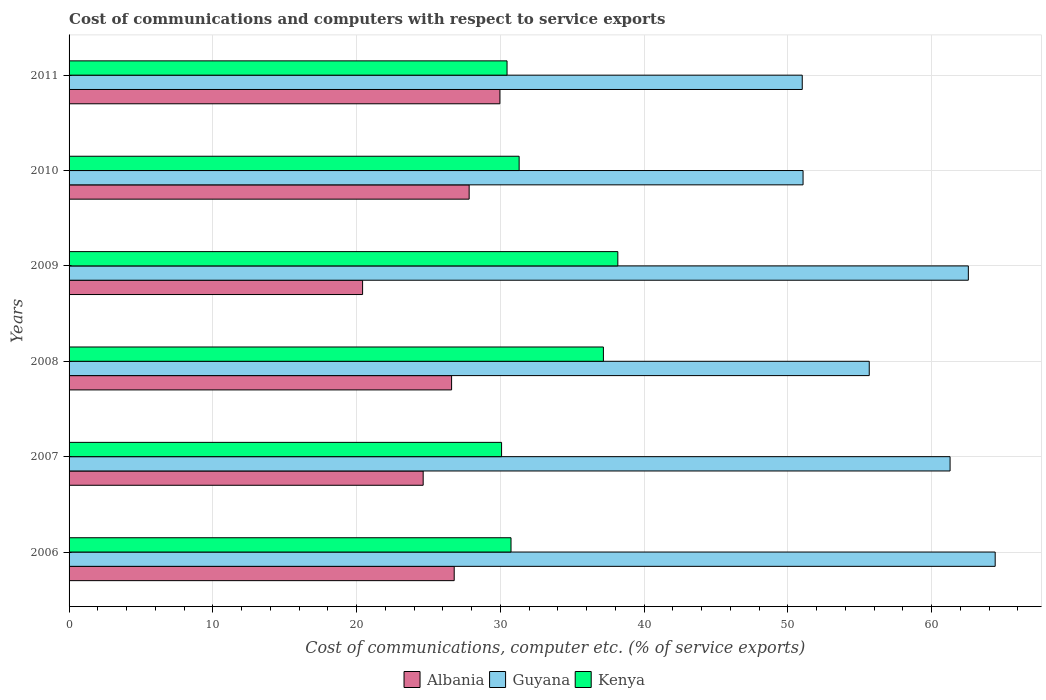How many different coloured bars are there?
Keep it short and to the point. 3. Are the number of bars per tick equal to the number of legend labels?
Your answer should be very brief. Yes. How many bars are there on the 6th tick from the bottom?
Ensure brevity in your answer.  3. What is the label of the 1st group of bars from the top?
Ensure brevity in your answer.  2011. In how many cases, is the number of bars for a given year not equal to the number of legend labels?
Your response must be concise. 0. What is the cost of communications and computers in Albania in 2008?
Ensure brevity in your answer.  26.61. Across all years, what is the maximum cost of communications and computers in Albania?
Offer a very short reply. 29.97. Across all years, what is the minimum cost of communications and computers in Guyana?
Ensure brevity in your answer.  51. In which year was the cost of communications and computers in Guyana minimum?
Offer a terse response. 2011. What is the total cost of communications and computers in Kenya in the graph?
Keep it short and to the point. 197.94. What is the difference between the cost of communications and computers in Albania in 2009 and that in 2010?
Ensure brevity in your answer.  -7.41. What is the difference between the cost of communications and computers in Albania in 2010 and the cost of communications and computers in Guyana in 2008?
Ensure brevity in your answer.  -27.83. What is the average cost of communications and computers in Guyana per year?
Your answer should be compact. 57.66. In the year 2010, what is the difference between the cost of communications and computers in Albania and cost of communications and computers in Kenya?
Offer a terse response. -3.48. What is the ratio of the cost of communications and computers in Guyana in 2008 to that in 2011?
Your response must be concise. 1.09. Is the difference between the cost of communications and computers in Albania in 2007 and 2010 greater than the difference between the cost of communications and computers in Kenya in 2007 and 2010?
Your response must be concise. No. What is the difference between the highest and the second highest cost of communications and computers in Albania?
Provide a short and direct response. 2.14. What is the difference between the highest and the lowest cost of communications and computers in Albania?
Make the answer very short. 9.55. In how many years, is the cost of communications and computers in Albania greater than the average cost of communications and computers in Albania taken over all years?
Your response must be concise. 4. Is the sum of the cost of communications and computers in Guyana in 2007 and 2009 greater than the maximum cost of communications and computers in Albania across all years?
Offer a terse response. Yes. What does the 2nd bar from the top in 2011 represents?
Ensure brevity in your answer.  Guyana. What does the 1st bar from the bottom in 2006 represents?
Offer a terse response. Albania. How many bars are there?
Provide a succinct answer. 18. Are all the bars in the graph horizontal?
Offer a terse response. Yes. How many years are there in the graph?
Ensure brevity in your answer.  6. What is the difference between two consecutive major ticks on the X-axis?
Your response must be concise. 10. Does the graph contain grids?
Provide a succinct answer. Yes. How many legend labels are there?
Ensure brevity in your answer.  3. What is the title of the graph?
Offer a terse response. Cost of communications and computers with respect to service exports. Does "Malawi" appear as one of the legend labels in the graph?
Make the answer very short. No. What is the label or title of the X-axis?
Ensure brevity in your answer.  Cost of communications, computer etc. (% of service exports). What is the Cost of communications, computer etc. (% of service exports) in Albania in 2006?
Your response must be concise. 26.79. What is the Cost of communications, computer etc. (% of service exports) of Guyana in 2006?
Provide a succinct answer. 64.42. What is the Cost of communications, computer etc. (% of service exports) in Kenya in 2006?
Give a very brief answer. 30.74. What is the Cost of communications, computer etc. (% of service exports) in Albania in 2007?
Make the answer very short. 24.63. What is the Cost of communications, computer etc. (% of service exports) in Guyana in 2007?
Your response must be concise. 61.28. What is the Cost of communications, computer etc. (% of service exports) of Kenya in 2007?
Provide a short and direct response. 30.09. What is the Cost of communications, computer etc. (% of service exports) in Albania in 2008?
Provide a short and direct response. 26.61. What is the Cost of communications, computer etc. (% of service exports) in Guyana in 2008?
Ensure brevity in your answer.  55.66. What is the Cost of communications, computer etc. (% of service exports) of Kenya in 2008?
Your answer should be very brief. 37.17. What is the Cost of communications, computer etc. (% of service exports) of Albania in 2009?
Your response must be concise. 20.42. What is the Cost of communications, computer etc. (% of service exports) of Guyana in 2009?
Offer a very short reply. 62.55. What is the Cost of communications, computer etc. (% of service exports) in Kenya in 2009?
Make the answer very short. 38.17. What is the Cost of communications, computer etc. (% of service exports) in Albania in 2010?
Your response must be concise. 27.83. What is the Cost of communications, computer etc. (% of service exports) of Guyana in 2010?
Give a very brief answer. 51.06. What is the Cost of communications, computer etc. (% of service exports) of Kenya in 2010?
Give a very brief answer. 31.31. What is the Cost of communications, computer etc. (% of service exports) in Albania in 2011?
Give a very brief answer. 29.97. What is the Cost of communications, computer etc. (% of service exports) in Guyana in 2011?
Your answer should be compact. 51. What is the Cost of communications, computer etc. (% of service exports) of Kenya in 2011?
Ensure brevity in your answer.  30.47. Across all years, what is the maximum Cost of communications, computer etc. (% of service exports) in Albania?
Ensure brevity in your answer.  29.97. Across all years, what is the maximum Cost of communications, computer etc. (% of service exports) of Guyana?
Make the answer very short. 64.42. Across all years, what is the maximum Cost of communications, computer etc. (% of service exports) in Kenya?
Your answer should be very brief. 38.17. Across all years, what is the minimum Cost of communications, computer etc. (% of service exports) in Albania?
Your answer should be very brief. 20.42. Across all years, what is the minimum Cost of communications, computer etc. (% of service exports) of Guyana?
Keep it short and to the point. 51. Across all years, what is the minimum Cost of communications, computer etc. (% of service exports) of Kenya?
Your answer should be compact. 30.09. What is the total Cost of communications, computer etc. (% of service exports) of Albania in the graph?
Your answer should be compact. 156.25. What is the total Cost of communications, computer etc. (% of service exports) in Guyana in the graph?
Provide a succinct answer. 345.98. What is the total Cost of communications, computer etc. (% of service exports) of Kenya in the graph?
Give a very brief answer. 197.94. What is the difference between the Cost of communications, computer etc. (% of service exports) of Albania in 2006 and that in 2007?
Keep it short and to the point. 2.16. What is the difference between the Cost of communications, computer etc. (% of service exports) in Guyana in 2006 and that in 2007?
Offer a terse response. 3.14. What is the difference between the Cost of communications, computer etc. (% of service exports) of Kenya in 2006 and that in 2007?
Provide a succinct answer. 0.66. What is the difference between the Cost of communications, computer etc. (% of service exports) in Albania in 2006 and that in 2008?
Give a very brief answer. 0.18. What is the difference between the Cost of communications, computer etc. (% of service exports) of Guyana in 2006 and that in 2008?
Give a very brief answer. 8.76. What is the difference between the Cost of communications, computer etc. (% of service exports) of Kenya in 2006 and that in 2008?
Offer a very short reply. -6.43. What is the difference between the Cost of communications, computer etc. (% of service exports) of Albania in 2006 and that in 2009?
Keep it short and to the point. 6.37. What is the difference between the Cost of communications, computer etc. (% of service exports) of Guyana in 2006 and that in 2009?
Your response must be concise. 1.87. What is the difference between the Cost of communications, computer etc. (% of service exports) in Kenya in 2006 and that in 2009?
Offer a terse response. -7.43. What is the difference between the Cost of communications, computer etc. (% of service exports) of Albania in 2006 and that in 2010?
Make the answer very short. -1.04. What is the difference between the Cost of communications, computer etc. (% of service exports) in Guyana in 2006 and that in 2010?
Your answer should be compact. 13.36. What is the difference between the Cost of communications, computer etc. (% of service exports) of Kenya in 2006 and that in 2010?
Offer a very short reply. -0.56. What is the difference between the Cost of communications, computer etc. (% of service exports) in Albania in 2006 and that in 2011?
Keep it short and to the point. -3.18. What is the difference between the Cost of communications, computer etc. (% of service exports) in Guyana in 2006 and that in 2011?
Your answer should be very brief. 13.42. What is the difference between the Cost of communications, computer etc. (% of service exports) in Kenya in 2006 and that in 2011?
Your answer should be very brief. 0.28. What is the difference between the Cost of communications, computer etc. (% of service exports) in Albania in 2007 and that in 2008?
Your response must be concise. -1.98. What is the difference between the Cost of communications, computer etc. (% of service exports) of Guyana in 2007 and that in 2008?
Your answer should be compact. 5.62. What is the difference between the Cost of communications, computer etc. (% of service exports) of Kenya in 2007 and that in 2008?
Your answer should be compact. -7.08. What is the difference between the Cost of communications, computer etc. (% of service exports) in Albania in 2007 and that in 2009?
Ensure brevity in your answer.  4.21. What is the difference between the Cost of communications, computer etc. (% of service exports) of Guyana in 2007 and that in 2009?
Your response must be concise. -1.27. What is the difference between the Cost of communications, computer etc. (% of service exports) in Kenya in 2007 and that in 2009?
Ensure brevity in your answer.  -8.09. What is the difference between the Cost of communications, computer etc. (% of service exports) in Albania in 2007 and that in 2010?
Your answer should be compact. -3.2. What is the difference between the Cost of communications, computer etc. (% of service exports) in Guyana in 2007 and that in 2010?
Make the answer very short. 10.23. What is the difference between the Cost of communications, computer etc. (% of service exports) in Kenya in 2007 and that in 2010?
Keep it short and to the point. -1.22. What is the difference between the Cost of communications, computer etc. (% of service exports) of Albania in 2007 and that in 2011?
Offer a terse response. -5.34. What is the difference between the Cost of communications, computer etc. (% of service exports) of Guyana in 2007 and that in 2011?
Provide a short and direct response. 10.28. What is the difference between the Cost of communications, computer etc. (% of service exports) of Kenya in 2007 and that in 2011?
Keep it short and to the point. -0.38. What is the difference between the Cost of communications, computer etc. (% of service exports) in Albania in 2008 and that in 2009?
Keep it short and to the point. 6.19. What is the difference between the Cost of communications, computer etc. (% of service exports) of Guyana in 2008 and that in 2009?
Provide a short and direct response. -6.89. What is the difference between the Cost of communications, computer etc. (% of service exports) in Kenya in 2008 and that in 2009?
Ensure brevity in your answer.  -1. What is the difference between the Cost of communications, computer etc. (% of service exports) of Albania in 2008 and that in 2010?
Offer a very short reply. -1.22. What is the difference between the Cost of communications, computer etc. (% of service exports) in Guyana in 2008 and that in 2010?
Offer a very short reply. 4.6. What is the difference between the Cost of communications, computer etc. (% of service exports) of Kenya in 2008 and that in 2010?
Provide a succinct answer. 5.86. What is the difference between the Cost of communications, computer etc. (% of service exports) in Albania in 2008 and that in 2011?
Make the answer very short. -3.36. What is the difference between the Cost of communications, computer etc. (% of service exports) of Guyana in 2008 and that in 2011?
Make the answer very short. 4.66. What is the difference between the Cost of communications, computer etc. (% of service exports) of Kenya in 2008 and that in 2011?
Make the answer very short. 6.7. What is the difference between the Cost of communications, computer etc. (% of service exports) in Albania in 2009 and that in 2010?
Offer a very short reply. -7.41. What is the difference between the Cost of communications, computer etc. (% of service exports) in Guyana in 2009 and that in 2010?
Keep it short and to the point. 11.5. What is the difference between the Cost of communications, computer etc. (% of service exports) in Kenya in 2009 and that in 2010?
Your response must be concise. 6.87. What is the difference between the Cost of communications, computer etc. (% of service exports) in Albania in 2009 and that in 2011?
Provide a short and direct response. -9.55. What is the difference between the Cost of communications, computer etc. (% of service exports) of Guyana in 2009 and that in 2011?
Provide a succinct answer. 11.55. What is the difference between the Cost of communications, computer etc. (% of service exports) of Kenya in 2009 and that in 2011?
Provide a short and direct response. 7.71. What is the difference between the Cost of communications, computer etc. (% of service exports) in Albania in 2010 and that in 2011?
Your response must be concise. -2.14. What is the difference between the Cost of communications, computer etc. (% of service exports) of Guyana in 2010 and that in 2011?
Your answer should be compact. 0.06. What is the difference between the Cost of communications, computer etc. (% of service exports) of Kenya in 2010 and that in 2011?
Provide a short and direct response. 0.84. What is the difference between the Cost of communications, computer etc. (% of service exports) in Albania in 2006 and the Cost of communications, computer etc. (% of service exports) in Guyana in 2007?
Your response must be concise. -34.49. What is the difference between the Cost of communications, computer etc. (% of service exports) in Albania in 2006 and the Cost of communications, computer etc. (% of service exports) in Kenya in 2007?
Your response must be concise. -3.3. What is the difference between the Cost of communications, computer etc. (% of service exports) of Guyana in 2006 and the Cost of communications, computer etc. (% of service exports) of Kenya in 2007?
Your answer should be very brief. 34.34. What is the difference between the Cost of communications, computer etc. (% of service exports) of Albania in 2006 and the Cost of communications, computer etc. (% of service exports) of Guyana in 2008?
Your response must be concise. -28.87. What is the difference between the Cost of communications, computer etc. (% of service exports) of Albania in 2006 and the Cost of communications, computer etc. (% of service exports) of Kenya in 2008?
Your response must be concise. -10.38. What is the difference between the Cost of communications, computer etc. (% of service exports) in Guyana in 2006 and the Cost of communications, computer etc. (% of service exports) in Kenya in 2008?
Give a very brief answer. 27.25. What is the difference between the Cost of communications, computer etc. (% of service exports) of Albania in 2006 and the Cost of communications, computer etc. (% of service exports) of Guyana in 2009?
Provide a short and direct response. -35.76. What is the difference between the Cost of communications, computer etc. (% of service exports) in Albania in 2006 and the Cost of communications, computer etc. (% of service exports) in Kenya in 2009?
Offer a very short reply. -11.38. What is the difference between the Cost of communications, computer etc. (% of service exports) of Guyana in 2006 and the Cost of communications, computer etc. (% of service exports) of Kenya in 2009?
Offer a very short reply. 26.25. What is the difference between the Cost of communications, computer etc. (% of service exports) of Albania in 2006 and the Cost of communications, computer etc. (% of service exports) of Guyana in 2010?
Ensure brevity in your answer.  -24.27. What is the difference between the Cost of communications, computer etc. (% of service exports) of Albania in 2006 and the Cost of communications, computer etc. (% of service exports) of Kenya in 2010?
Give a very brief answer. -4.52. What is the difference between the Cost of communications, computer etc. (% of service exports) in Guyana in 2006 and the Cost of communications, computer etc. (% of service exports) in Kenya in 2010?
Make the answer very short. 33.11. What is the difference between the Cost of communications, computer etc. (% of service exports) in Albania in 2006 and the Cost of communications, computer etc. (% of service exports) in Guyana in 2011?
Offer a terse response. -24.21. What is the difference between the Cost of communications, computer etc. (% of service exports) in Albania in 2006 and the Cost of communications, computer etc. (% of service exports) in Kenya in 2011?
Provide a succinct answer. -3.68. What is the difference between the Cost of communications, computer etc. (% of service exports) of Guyana in 2006 and the Cost of communications, computer etc. (% of service exports) of Kenya in 2011?
Offer a very short reply. 33.96. What is the difference between the Cost of communications, computer etc. (% of service exports) of Albania in 2007 and the Cost of communications, computer etc. (% of service exports) of Guyana in 2008?
Provide a short and direct response. -31.03. What is the difference between the Cost of communications, computer etc. (% of service exports) of Albania in 2007 and the Cost of communications, computer etc. (% of service exports) of Kenya in 2008?
Provide a short and direct response. -12.54. What is the difference between the Cost of communications, computer etc. (% of service exports) of Guyana in 2007 and the Cost of communications, computer etc. (% of service exports) of Kenya in 2008?
Your answer should be compact. 24.12. What is the difference between the Cost of communications, computer etc. (% of service exports) in Albania in 2007 and the Cost of communications, computer etc. (% of service exports) in Guyana in 2009?
Your answer should be compact. -37.92. What is the difference between the Cost of communications, computer etc. (% of service exports) of Albania in 2007 and the Cost of communications, computer etc. (% of service exports) of Kenya in 2009?
Your answer should be compact. -13.54. What is the difference between the Cost of communications, computer etc. (% of service exports) in Guyana in 2007 and the Cost of communications, computer etc. (% of service exports) in Kenya in 2009?
Your response must be concise. 23.11. What is the difference between the Cost of communications, computer etc. (% of service exports) in Albania in 2007 and the Cost of communications, computer etc. (% of service exports) in Guyana in 2010?
Provide a succinct answer. -26.43. What is the difference between the Cost of communications, computer etc. (% of service exports) in Albania in 2007 and the Cost of communications, computer etc. (% of service exports) in Kenya in 2010?
Offer a terse response. -6.68. What is the difference between the Cost of communications, computer etc. (% of service exports) in Guyana in 2007 and the Cost of communications, computer etc. (% of service exports) in Kenya in 2010?
Provide a succinct answer. 29.98. What is the difference between the Cost of communications, computer etc. (% of service exports) in Albania in 2007 and the Cost of communications, computer etc. (% of service exports) in Guyana in 2011?
Offer a terse response. -26.37. What is the difference between the Cost of communications, computer etc. (% of service exports) of Albania in 2007 and the Cost of communications, computer etc. (% of service exports) of Kenya in 2011?
Give a very brief answer. -5.83. What is the difference between the Cost of communications, computer etc. (% of service exports) in Guyana in 2007 and the Cost of communications, computer etc. (% of service exports) in Kenya in 2011?
Offer a very short reply. 30.82. What is the difference between the Cost of communications, computer etc. (% of service exports) of Albania in 2008 and the Cost of communications, computer etc. (% of service exports) of Guyana in 2009?
Your answer should be very brief. -35.95. What is the difference between the Cost of communications, computer etc. (% of service exports) in Albania in 2008 and the Cost of communications, computer etc. (% of service exports) in Kenya in 2009?
Your answer should be very brief. -11.56. What is the difference between the Cost of communications, computer etc. (% of service exports) of Guyana in 2008 and the Cost of communications, computer etc. (% of service exports) of Kenya in 2009?
Keep it short and to the point. 17.49. What is the difference between the Cost of communications, computer etc. (% of service exports) of Albania in 2008 and the Cost of communications, computer etc. (% of service exports) of Guyana in 2010?
Provide a succinct answer. -24.45. What is the difference between the Cost of communications, computer etc. (% of service exports) of Albania in 2008 and the Cost of communications, computer etc. (% of service exports) of Kenya in 2010?
Provide a succinct answer. -4.7. What is the difference between the Cost of communications, computer etc. (% of service exports) in Guyana in 2008 and the Cost of communications, computer etc. (% of service exports) in Kenya in 2010?
Ensure brevity in your answer.  24.35. What is the difference between the Cost of communications, computer etc. (% of service exports) of Albania in 2008 and the Cost of communications, computer etc. (% of service exports) of Guyana in 2011?
Offer a very short reply. -24.39. What is the difference between the Cost of communications, computer etc. (% of service exports) of Albania in 2008 and the Cost of communications, computer etc. (% of service exports) of Kenya in 2011?
Offer a terse response. -3.86. What is the difference between the Cost of communications, computer etc. (% of service exports) of Guyana in 2008 and the Cost of communications, computer etc. (% of service exports) of Kenya in 2011?
Your answer should be compact. 25.2. What is the difference between the Cost of communications, computer etc. (% of service exports) in Albania in 2009 and the Cost of communications, computer etc. (% of service exports) in Guyana in 2010?
Your answer should be very brief. -30.64. What is the difference between the Cost of communications, computer etc. (% of service exports) of Albania in 2009 and the Cost of communications, computer etc. (% of service exports) of Kenya in 2010?
Ensure brevity in your answer.  -10.89. What is the difference between the Cost of communications, computer etc. (% of service exports) in Guyana in 2009 and the Cost of communications, computer etc. (% of service exports) in Kenya in 2010?
Ensure brevity in your answer.  31.25. What is the difference between the Cost of communications, computer etc. (% of service exports) in Albania in 2009 and the Cost of communications, computer etc. (% of service exports) in Guyana in 2011?
Your answer should be compact. -30.58. What is the difference between the Cost of communications, computer etc. (% of service exports) of Albania in 2009 and the Cost of communications, computer etc. (% of service exports) of Kenya in 2011?
Provide a short and direct response. -10.05. What is the difference between the Cost of communications, computer etc. (% of service exports) of Guyana in 2009 and the Cost of communications, computer etc. (% of service exports) of Kenya in 2011?
Provide a succinct answer. 32.09. What is the difference between the Cost of communications, computer etc. (% of service exports) in Albania in 2010 and the Cost of communications, computer etc. (% of service exports) in Guyana in 2011?
Make the answer very short. -23.17. What is the difference between the Cost of communications, computer etc. (% of service exports) in Albania in 2010 and the Cost of communications, computer etc. (% of service exports) in Kenya in 2011?
Make the answer very short. -2.63. What is the difference between the Cost of communications, computer etc. (% of service exports) in Guyana in 2010 and the Cost of communications, computer etc. (% of service exports) in Kenya in 2011?
Provide a succinct answer. 20.59. What is the average Cost of communications, computer etc. (% of service exports) in Albania per year?
Offer a very short reply. 26.04. What is the average Cost of communications, computer etc. (% of service exports) in Guyana per year?
Your answer should be very brief. 57.66. What is the average Cost of communications, computer etc. (% of service exports) of Kenya per year?
Offer a terse response. 32.99. In the year 2006, what is the difference between the Cost of communications, computer etc. (% of service exports) in Albania and Cost of communications, computer etc. (% of service exports) in Guyana?
Your answer should be compact. -37.63. In the year 2006, what is the difference between the Cost of communications, computer etc. (% of service exports) in Albania and Cost of communications, computer etc. (% of service exports) in Kenya?
Give a very brief answer. -3.95. In the year 2006, what is the difference between the Cost of communications, computer etc. (% of service exports) of Guyana and Cost of communications, computer etc. (% of service exports) of Kenya?
Ensure brevity in your answer.  33.68. In the year 2007, what is the difference between the Cost of communications, computer etc. (% of service exports) of Albania and Cost of communications, computer etc. (% of service exports) of Guyana?
Give a very brief answer. -36.65. In the year 2007, what is the difference between the Cost of communications, computer etc. (% of service exports) in Albania and Cost of communications, computer etc. (% of service exports) in Kenya?
Keep it short and to the point. -5.45. In the year 2007, what is the difference between the Cost of communications, computer etc. (% of service exports) of Guyana and Cost of communications, computer etc. (% of service exports) of Kenya?
Give a very brief answer. 31.2. In the year 2008, what is the difference between the Cost of communications, computer etc. (% of service exports) of Albania and Cost of communications, computer etc. (% of service exports) of Guyana?
Your answer should be very brief. -29.05. In the year 2008, what is the difference between the Cost of communications, computer etc. (% of service exports) of Albania and Cost of communications, computer etc. (% of service exports) of Kenya?
Your answer should be very brief. -10.56. In the year 2008, what is the difference between the Cost of communications, computer etc. (% of service exports) in Guyana and Cost of communications, computer etc. (% of service exports) in Kenya?
Keep it short and to the point. 18.49. In the year 2009, what is the difference between the Cost of communications, computer etc. (% of service exports) in Albania and Cost of communications, computer etc. (% of service exports) in Guyana?
Give a very brief answer. -42.14. In the year 2009, what is the difference between the Cost of communications, computer etc. (% of service exports) of Albania and Cost of communications, computer etc. (% of service exports) of Kenya?
Offer a very short reply. -17.76. In the year 2009, what is the difference between the Cost of communications, computer etc. (% of service exports) in Guyana and Cost of communications, computer etc. (% of service exports) in Kenya?
Ensure brevity in your answer.  24.38. In the year 2010, what is the difference between the Cost of communications, computer etc. (% of service exports) of Albania and Cost of communications, computer etc. (% of service exports) of Guyana?
Ensure brevity in your answer.  -23.23. In the year 2010, what is the difference between the Cost of communications, computer etc. (% of service exports) in Albania and Cost of communications, computer etc. (% of service exports) in Kenya?
Offer a terse response. -3.48. In the year 2010, what is the difference between the Cost of communications, computer etc. (% of service exports) of Guyana and Cost of communications, computer etc. (% of service exports) of Kenya?
Your answer should be very brief. 19.75. In the year 2011, what is the difference between the Cost of communications, computer etc. (% of service exports) in Albania and Cost of communications, computer etc. (% of service exports) in Guyana?
Ensure brevity in your answer.  -21.03. In the year 2011, what is the difference between the Cost of communications, computer etc. (% of service exports) in Albania and Cost of communications, computer etc. (% of service exports) in Kenya?
Your answer should be compact. -0.5. In the year 2011, what is the difference between the Cost of communications, computer etc. (% of service exports) of Guyana and Cost of communications, computer etc. (% of service exports) of Kenya?
Ensure brevity in your answer.  20.53. What is the ratio of the Cost of communications, computer etc. (% of service exports) in Albania in 2006 to that in 2007?
Ensure brevity in your answer.  1.09. What is the ratio of the Cost of communications, computer etc. (% of service exports) of Guyana in 2006 to that in 2007?
Offer a terse response. 1.05. What is the ratio of the Cost of communications, computer etc. (% of service exports) of Kenya in 2006 to that in 2007?
Ensure brevity in your answer.  1.02. What is the ratio of the Cost of communications, computer etc. (% of service exports) of Albania in 2006 to that in 2008?
Make the answer very short. 1.01. What is the ratio of the Cost of communications, computer etc. (% of service exports) of Guyana in 2006 to that in 2008?
Provide a succinct answer. 1.16. What is the ratio of the Cost of communications, computer etc. (% of service exports) of Kenya in 2006 to that in 2008?
Your response must be concise. 0.83. What is the ratio of the Cost of communications, computer etc. (% of service exports) of Albania in 2006 to that in 2009?
Your response must be concise. 1.31. What is the ratio of the Cost of communications, computer etc. (% of service exports) of Guyana in 2006 to that in 2009?
Ensure brevity in your answer.  1.03. What is the ratio of the Cost of communications, computer etc. (% of service exports) of Kenya in 2006 to that in 2009?
Give a very brief answer. 0.81. What is the ratio of the Cost of communications, computer etc. (% of service exports) in Albania in 2006 to that in 2010?
Keep it short and to the point. 0.96. What is the ratio of the Cost of communications, computer etc. (% of service exports) in Guyana in 2006 to that in 2010?
Keep it short and to the point. 1.26. What is the ratio of the Cost of communications, computer etc. (% of service exports) of Albania in 2006 to that in 2011?
Your answer should be very brief. 0.89. What is the ratio of the Cost of communications, computer etc. (% of service exports) in Guyana in 2006 to that in 2011?
Your answer should be compact. 1.26. What is the ratio of the Cost of communications, computer etc. (% of service exports) in Kenya in 2006 to that in 2011?
Your response must be concise. 1.01. What is the ratio of the Cost of communications, computer etc. (% of service exports) in Albania in 2007 to that in 2008?
Give a very brief answer. 0.93. What is the ratio of the Cost of communications, computer etc. (% of service exports) in Guyana in 2007 to that in 2008?
Provide a succinct answer. 1.1. What is the ratio of the Cost of communications, computer etc. (% of service exports) of Kenya in 2007 to that in 2008?
Offer a very short reply. 0.81. What is the ratio of the Cost of communications, computer etc. (% of service exports) in Albania in 2007 to that in 2009?
Offer a very short reply. 1.21. What is the ratio of the Cost of communications, computer etc. (% of service exports) of Guyana in 2007 to that in 2009?
Offer a very short reply. 0.98. What is the ratio of the Cost of communications, computer etc. (% of service exports) of Kenya in 2007 to that in 2009?
Your answer should be very brief. 0.79. What is the ratio of the Cost of communications, computer etc. (% of service exports) of Albania in 2007 to that in 2010?
Offer a very short reply. 0.89. What is the ratio of the Cost of communications, computer etc. (% of service exports) of Guyana in 2007 to that in 2010?
Ensure brevity in your answer.  1.2. What is the ratio of the Cost of communications, computer etc. (% of service exports) in Kenya in 2007 to that in 2010?
Offer a very short reply. 0.96. What is the ratio of the Cost of communications, computer etc. (% of service exports) in Albania in 2007 to that in 2011?
Keep it short and to the point. 0.82. What is the ratio of the Cost of communications, computer etc. (% of service exports) of Guyana in 2007 to that in 2011?
Keep it short and to the point. 1.2. What is the ratio of the Cost of communications, computer etc. (% of service exports) of Kenya in 2007 to that in 2011?
Offer a very short reply. 0.99. What is the ratio of the Cost of communications, computer etc. (% of service exports) of Albania in 2008 to that in 2009?
Give a very brief answer. 1.3. What is the ratio of the Cost of communications, computer etc. (% of service exports) in Guyana in 2008 to that in 2009?
Offer a terse response. 0.89. What is the ratio of the Cost of communications, computer etc. (% of service exports) in Kenya in 2008 to that in 2009?
Provide a succinct answer. 0.97. What is the ratio of the Cost of communications, computer etc. (% of service exports) of Albania in 2008 to that in 2010?
Your answer should be compact. 0.96. What is the ratio of the Cost of communications, computer etc. (% of service exports) of Guyana in 2008 to that in 2010?
Ensure brevity in your answer.  1.09. What is the ratio of the Cost of communications, computer etc. (% of service exports) in Kenya in 2008 to that in 2010?
Make the answer very short. 1.19. What is the ratio of the Cost of communications, computer etc. (% of service exports) of Albania in 2008 to that in 2011?
Keep it short and to the point. 0.89. What is the ratio of the Cost of communications, computer etc. (% of service exports) of Guyana in 2008 to that in 2011?
Offer a very short reply. 1.09. What is the ratio of the Cost of communications, computer etc. (% of service exports) in Kenya in 2008 to that in 2011?
Make the answer very short. 1.22. What is the ratio of the Cost of communications, computer etc. (% of service exports) of Albania in 2009 to that in 2010?
Offer a very short reply. 0.73. What is the ratio of the Cost of communications, computer etc. (% of service exports) in Guyana in 2009 to that in 2010?
Your answer should be compact. 1.23. What is the ratio of the Cost of communications, computer etc. (% of service exports) in Kenya in 2009 to that in 2010?
Make the answer very short. 1.22. What is the ratio of the Cost of communications, computer etc. (% of service exports) in Albania in 2009 to that in 2011?
Provide a short and direct response. 0.68. What is the ratio of the Cost of communications, computer etc. (% of service exports) in Guyana in 2009 to that in 2011?
Provide a succinct answer. 1.23. What is the ratio of the Cost of communications, computer etc. (% of service exports) in Kenya in 2009 to that in 2011?
Ensure brevity in your answer.  1.25. What is the ratio of the Cost of communications, computer etc. (% of service exports) in Albania in 2010 to that in 2011?
Offer a terse response. 0.93. What is the ratio of the Cost of communications, computer etc. (% of service exports) of Kenya in 2010 to that in 2011?
Provide a short and direct response. 1.03. What is the difference between the highest and the second highest Cost of communications, computer etc. (% of service exports) in Albania?
Ensure brevity in your answer.  2.14. What is the difference between the highest and the second highest Cost of communications, computer etc. (% of service exports) of Guyana?
Give a very brief answer. 1.87. What is the difference between the highest and the second highest Cost of communications, computer etc. (% of service exports) in Kenya?
Your answer should be very brief. 1. What is the difference between the highest and the lowest Cost of communications, computer etc. (% of service exports) in Albania?
Provide a short and direct response. 9.55. What is the difference between the highest and the lowest Cost of communications, computer etc. (% of service exports) in Guyana?
Provide a short and direct response. 13.42. What is the difference between the highest and the lowest Cost of communications, computer etc. (% of service exports) in Kenya?
Offer a very short reply. 8.09. 